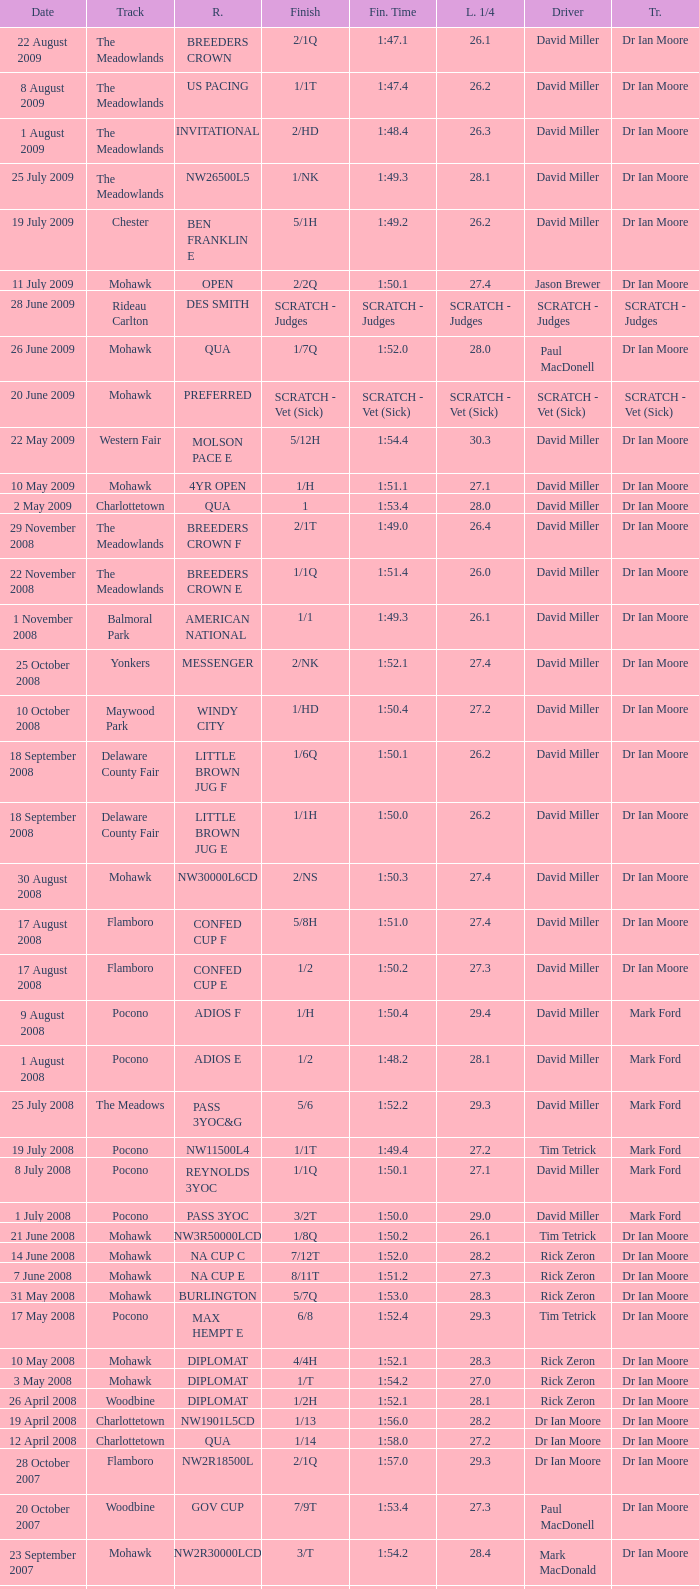What is the finishing time with a 2/1q finish on the Meadowlands track? 1:47.1. 